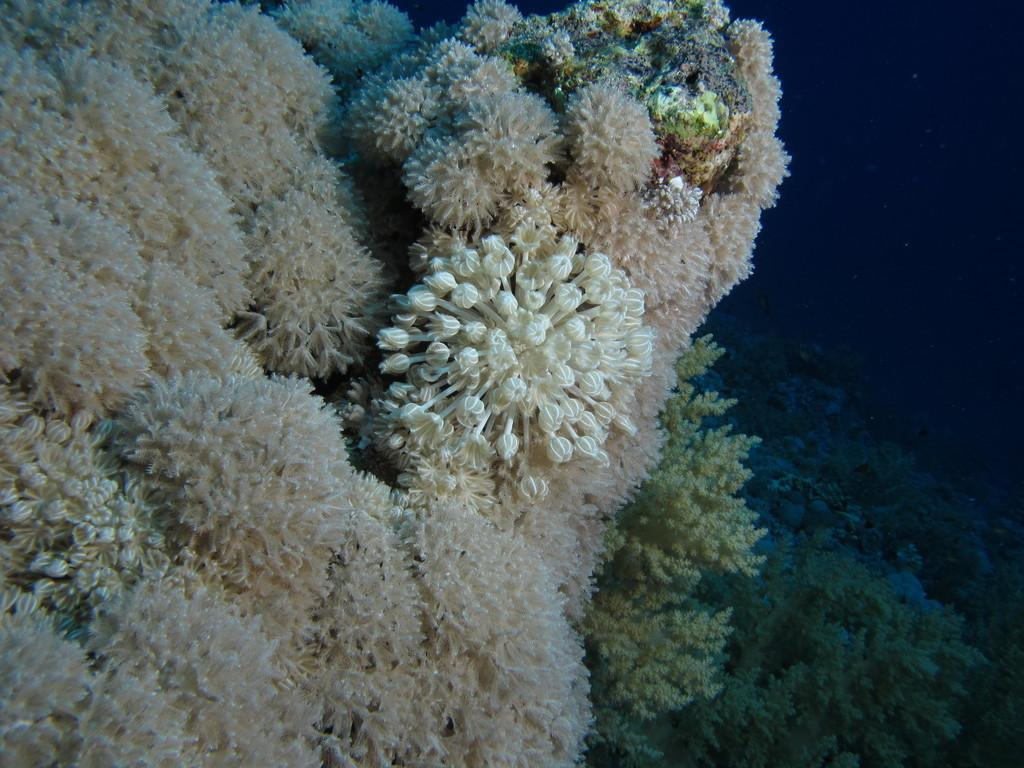What type of plants are visible in the image? There are underwater plants in the image. How many apples are hanging from the tree in the image? There is no tree or apple present in the image; it features underwater plants. What color are the eyes of the creature in the image? There is no creature with eyes present in the image; it features underwater plants. 